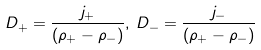Convert formula to latex. <formula><loc_0><loc_0><loc_500><loc_500>D _ { + } = \frac { j _ { + } } { ( \rho _ { + } - \rho _ { - } ) } , \, D _ { - } = \frac { j _ { - } } { ( \rho _ { + } - \rho _ { - } ) }</formula> 